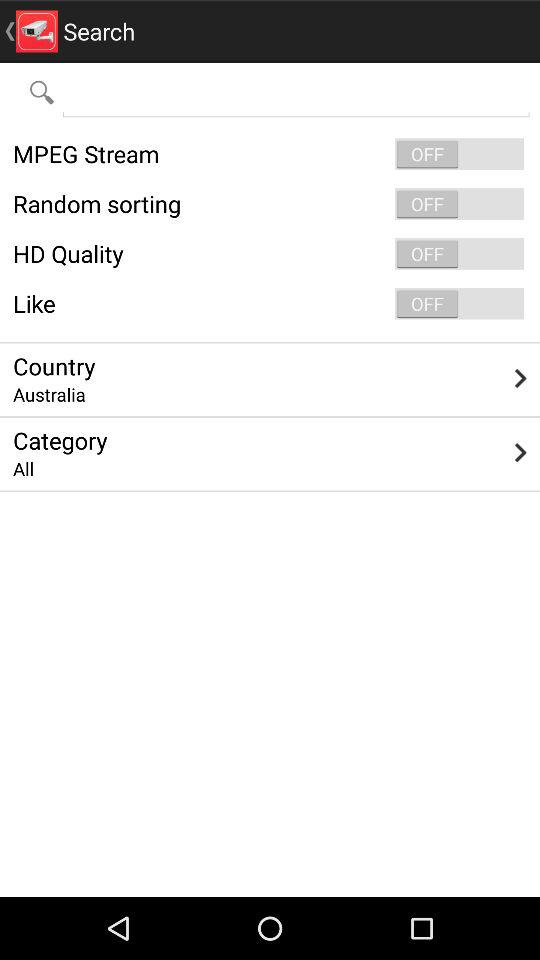What is the selected country? The selected country is "Australia". 